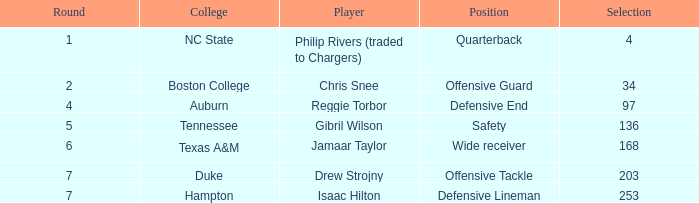Write the full table. {'header': ['Round', 'College', 'Player', 'Position', 'Selection'], 'rows': [['1', 'NC State', 'Philip Rivers (traded to Chargers)', 'Quarterback', '4'], ['2', 'Boston College', 'Chris Snee', 'Offensive Guard', '34'], ['4', 'Auburn', 'Reggie Torbor', 'Defensive End', '97'], ['5', 'Tennessee', 'Gibril Wilson', 'Safety', '136'], ['6', 'Texas A&M', 'Jamaar Taylor', 'Wide receiver', '168'], ['7', 'Duke', 'Drew Strojny', 'Offensive Tackle', '203'], ['7', 'Hampton', 'Isaac Hilton', 'Defensive Lineman', '253']]} Which Selection has a Player of jamaar taylor, and a Round larger than 6? None. 